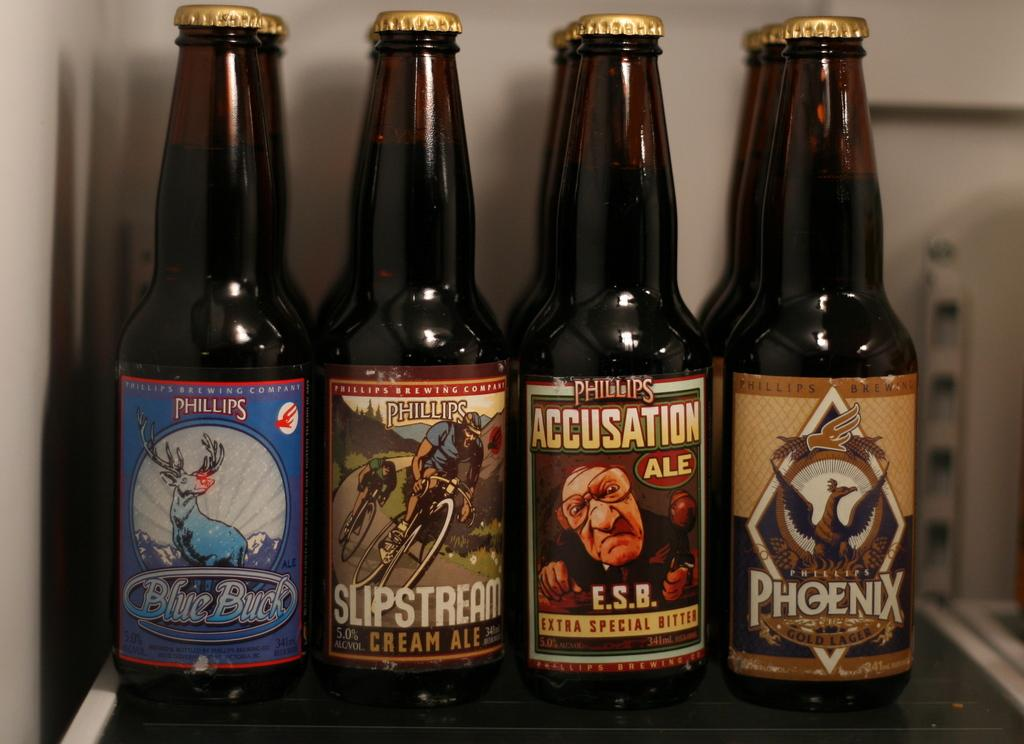<image>
Present a compact description of the photo's key features. Four closed black bottles by the brand Phillips. 